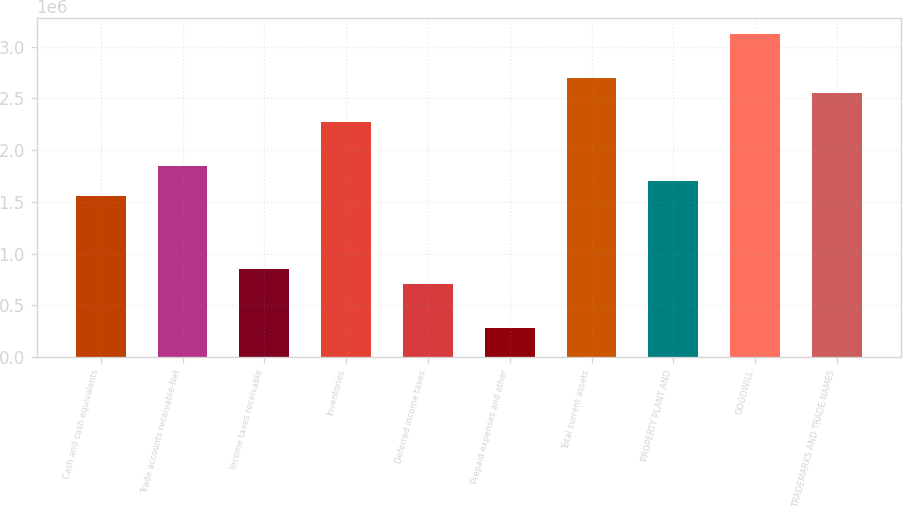<chart> <loc_0><loc_0><loc_500><loc_500><bar_chart><fcel>Cash and cash equivalents<fcel>Trade accounts receivable-Net<fcel>Income taxes receivable<fcel>Inventories<fcel>Deferred income taxes<fcel>Prepaid expenses and other<fcel>Total current assets<fcel>PROPERTY PLANT AND<fcel>GOODWILL<fcel>TRADEMARKS AND TRADE NAMES<nl><fcel>1.55834e+06<fcel>1.84159e+06<fcel>850206<fcel>2.26647e+06<fcel>708579<fcel>283699<fcel>2.69135e+06<fcel>1.69997e+06<fcel>3.11623e+06<fcel>2.54972e+06<nl></chart> 